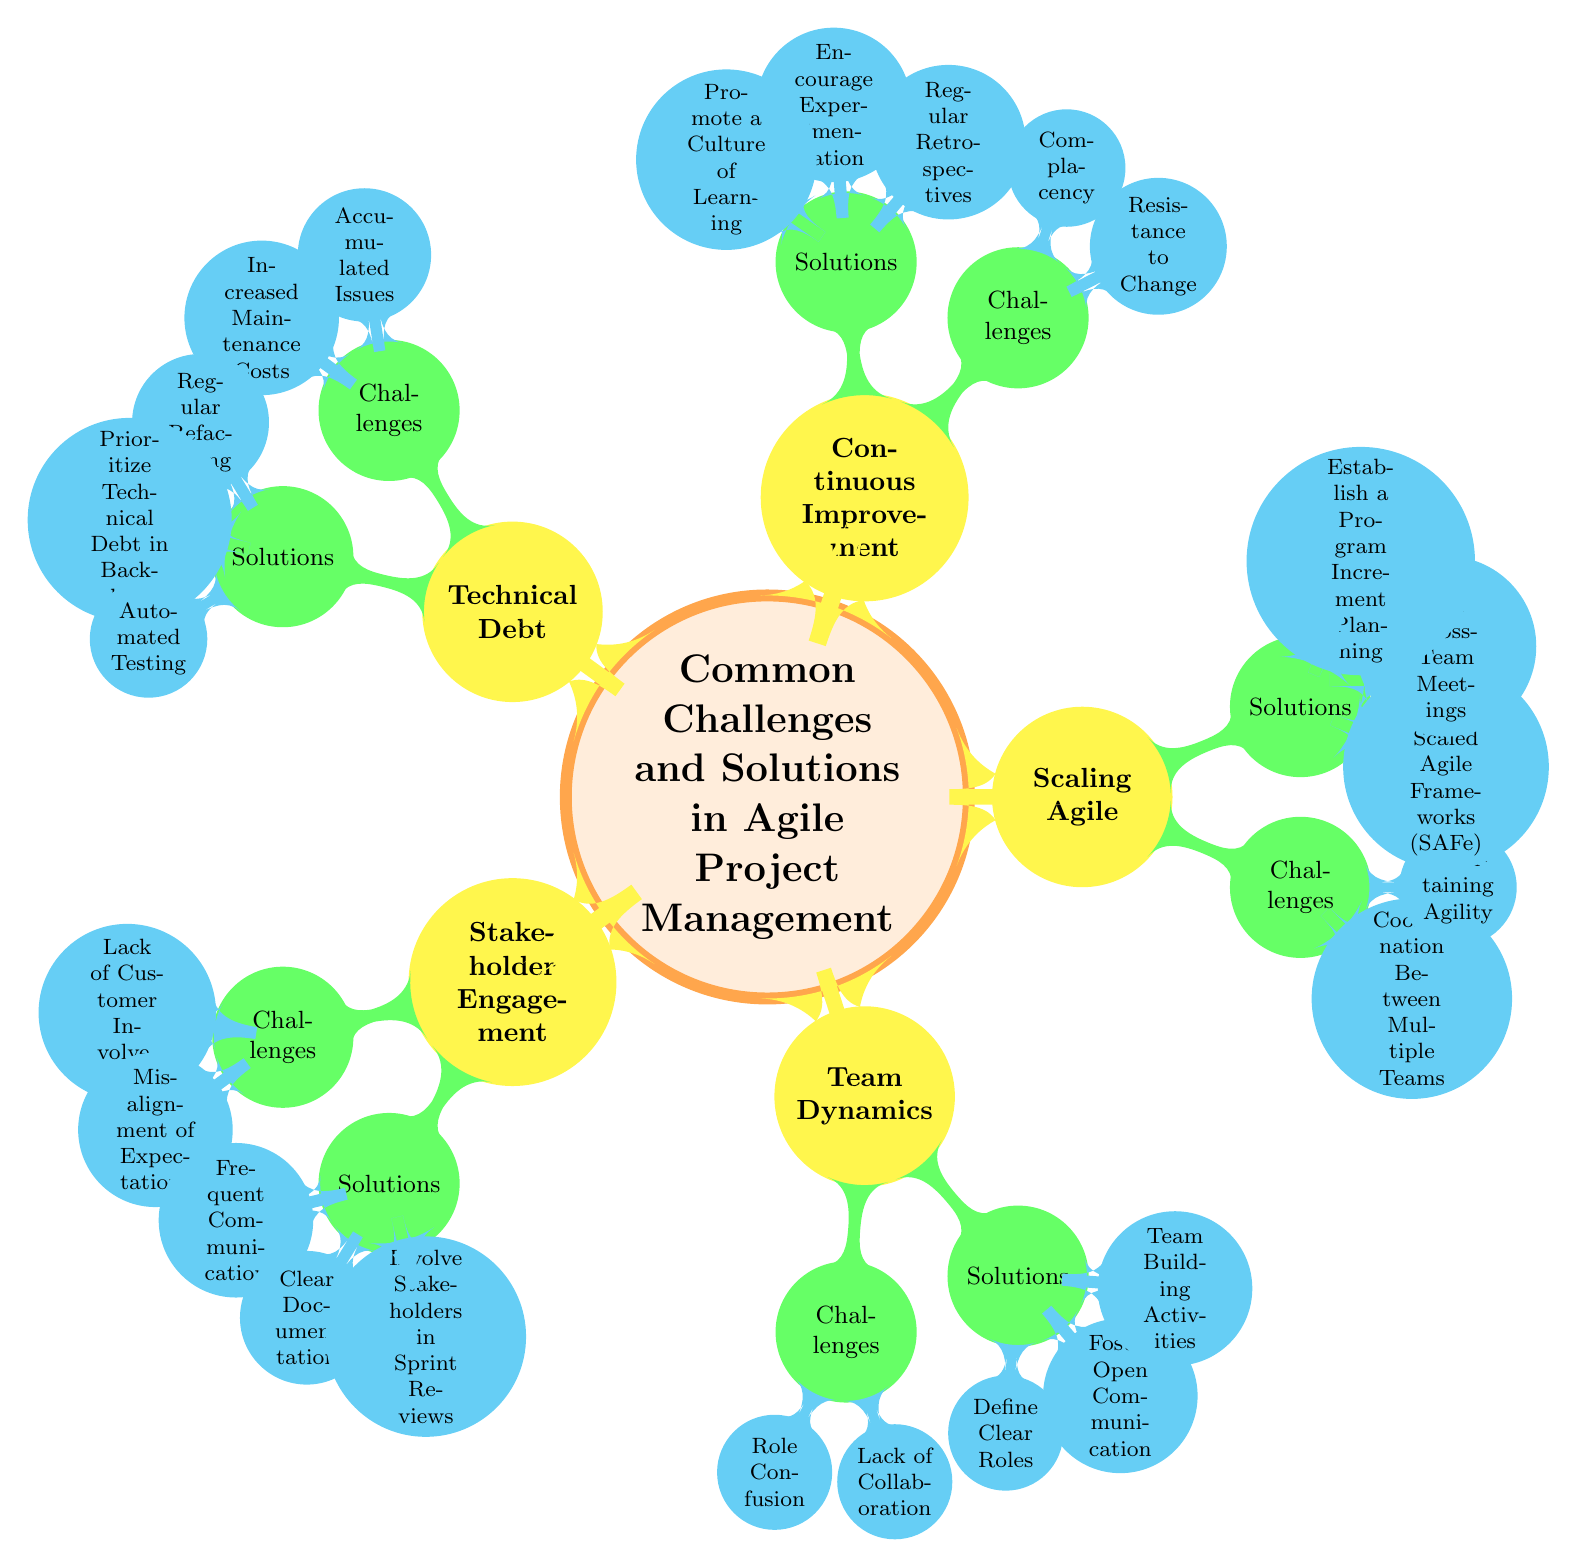What is the primary focus of the mind map? The central node of the mind map is labeled "Common Challenges and Solutions in Agile Project Management," indicating that all information within the diagram revolves around this theme.
Answer: Common Challenges and Solutions in Agile Project Management How many main categories are presented in the diagram? Upon counting the main branches of the mind map stemming from the central node, we find five main categories: Stakeholder Engagement, Team Dynamics, Scaling Agile, Continuous Improvement, and Technical Debt.
Answer: 5 What challenge is associated with Stakeholder Engagement? The challenges node under Stakeholder Engagement lists "Lack of Customer Involvement" and "Misalignment of Expectations." Both are recorded challenges under this category.
Answer: Lack of Customer Involvement Which category has the solution of "Establish a Program Increment Planning"? By identifying the solutions beneath each category, we see that "Establish a Program Increment Planning" is listed as a solution under the Scaling Agile category.
Answer: Scaling Agile How are the challenges related to Team Dynamics described? The challenges under Team Dynamics include "Role Confusion" and "Lack of Collaboration," which both focus on issues related to team interactions and clarity of roles.
Answer: Role Confusion, Lack of Collaboration What is one solution provided for Continuous Improvement? The solutions node for Continuous Improvement lists three strategies, including "Regular Retrospectives," which is one method suggested to facilitate continuous improvement efforts.
Answer: Regular Retrospectives Which two challenges are faced regarding Technical Debt? Looking at the challenges listed under Technical Debt, we identify "Accumulated Issues" and "Increased Maintenance Costs," both reflecting common problems associated with technical debt within projects.
Answer: Accumulated Issues, Increased Maintenance Costs What type of framework is suggested under Scaling Agile? Among the solutions provided under Scaling Agile, it specifically mentions "Implement Scaled Agile Frameworks (SAFe)," which is the type of framework suggested for scaling agile methods in projects.
Answer: Implement Scaled Agile Frameworks (SAFe) 